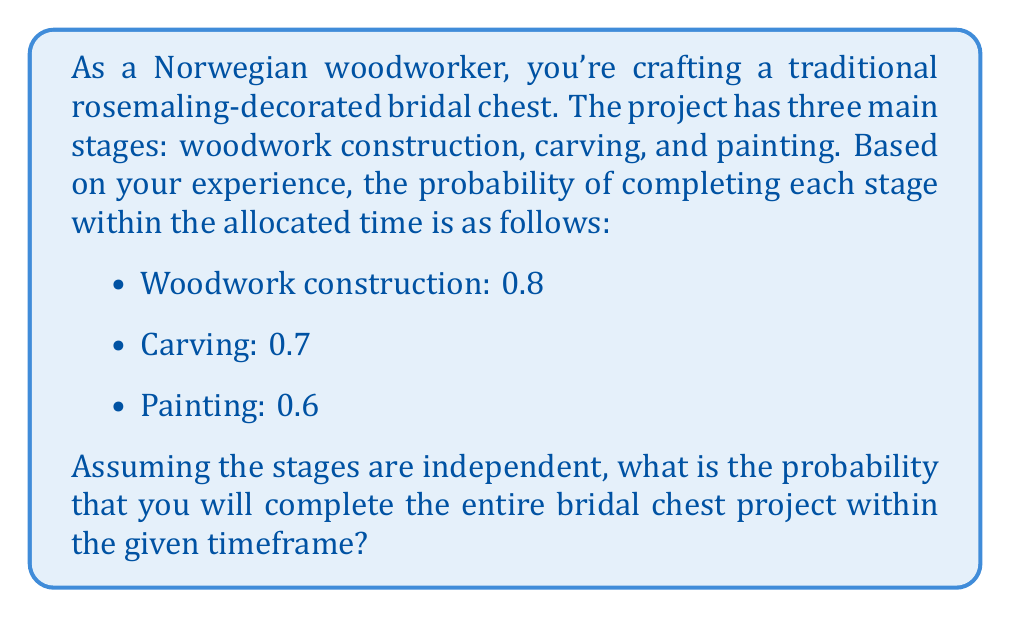Solve this math problem. To solve this problem, we need to understand that the successful completion of the entire project requires the successful completion of all three stages within their allocated times. Since the stages are independent, we can use the multiplication rule of probability.

Let's define the events:
- A: Completing woodwork construction on time
- B: Completing carving on time
- C: Completing painting on time

We're given:
- P(A) = 0.8
- P(B) = 0.7
- P(C) = 0.6

The probability of completing all stages on time is:

$$ P(A \cap B \cap C) = P(A) \times P(B) \times P(C) $$

Substituting the values:

$$ P(A \cap B \cap C) = 0.8 \times 0.7 \times 0.6 $$

$$ P(A \cap B \cap C) = 0.336 $$

Therefore, the probability of completing the entire bridal chest project within the given timeframe is 0.336 or 33.6%.
Answer: The probability of completing the entire bridal chest project within the given timeframe is 0.336 or 33.6%. 